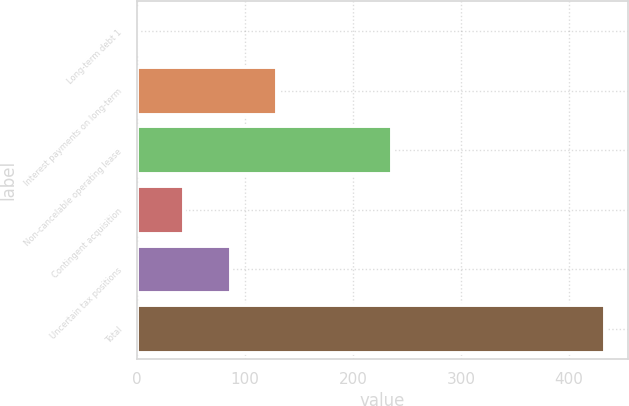Convert chart to OTSL. <chart><loc_0><loc_0><loc_500><loc_500><bar_chart><fcel>Long-term debt 1<fcel>Interest payments on long-term<fcel>Non-cancelable operating lease<fcel>Contingent acquisition<fcel>Uncertain tax positions<fcel>Total<nl><fcel>0.1<fcel>130<fcel>236.1<fcel>43.4<fcel>86.7<fcel>433.1<nl></chart> 